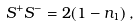<formula> <loc_0><loc_0><loc_500><loc_500>S ^ { + } S ^ { - } = 2 ( 1 - n _ { 1 } ) \, ,</formula> 